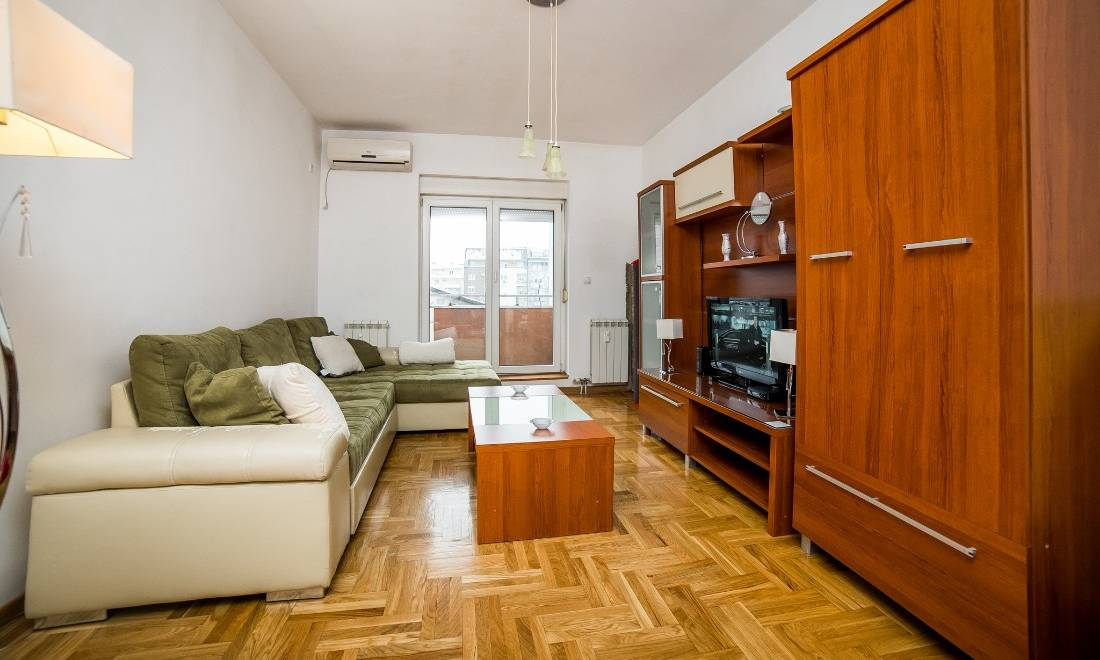What can be deduced about the owner's lifestyle based on the setting and furniture arrangement? The setting suggests a lifestyle that values comfort and practicality. The L-shaped sofa indicates a preference for socializing with guests or lounging comfortably, while the modest entertainment unit hints at an enjoyment of movies or television in a cozy environment. The clean and organized appearance signifies that the owner maintains a tidy home, possibly valuing a balanced and orderly life. The neutral color palette and minimal decor suggest a taste for simplicity and functional design. How might the furniture arrangement reflect on the owner's priorities at home? The furniture arrangement reflects a prioritization of functionality and comfort. The L-shaped sofa is ideally placed to maximize seating and provide a comfortable spot to relax or entertain. The placement of the television within easy view from the sofa suggests that entertainment and relaxation are important aspects of the owner’s home life. The coffee table serves as a central point for convenience, perhaps for placing drinks, remote controls, or reading materials, indicating a practical approach to the living space. Overall, the arrangement reveals a preference for a comfortable, uncluttered, and efficient home environment. 